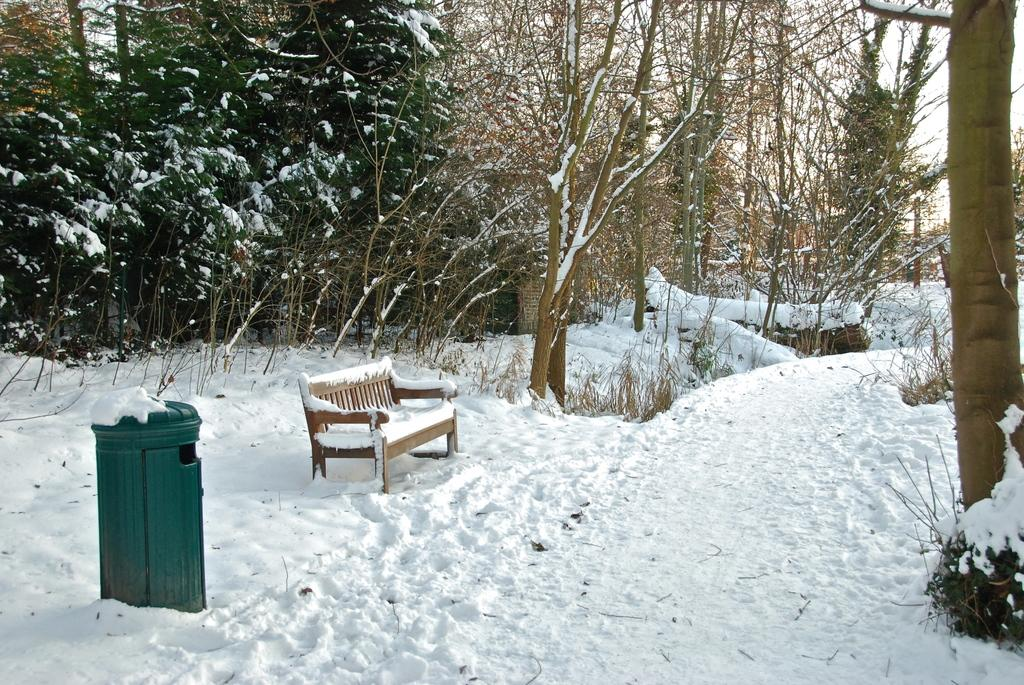What object is visible in the image that is typically used for waste disposal? There is a dustbin in the image. What type of seating is present in the image? There is a bench in the image. How is the dustbin and bench affected by the weather in the image? Both the dustbin and bench are covered with snow. Where are the dustbin and bench located in the image? The dustbin and bench are in the snow. What can be seen in the background of the image? There are trees, plants, and the sky visible in the background of the image. What type of brass instrument is being played by the nation in the image? There is no brass instrument or nation present in the image. 